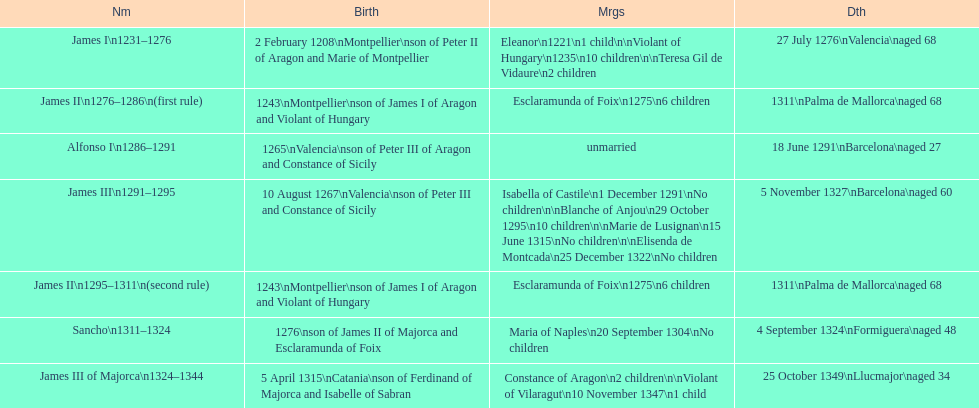What is the overall number of marriages james i had? 3. 